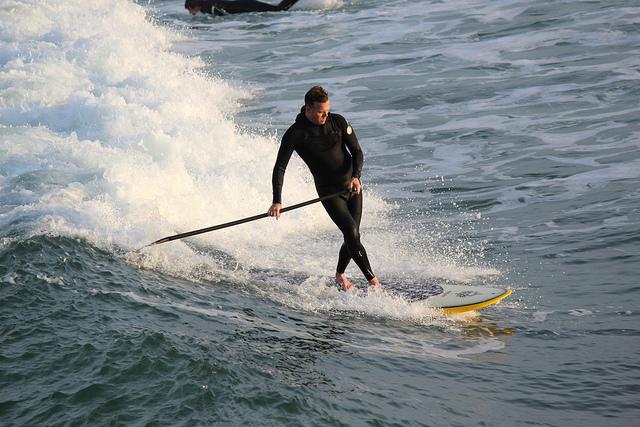What is the man holding on to?
Quick response, please. Paddle. What sport is this?
Give a very brief answer. Surfing. Is this person flying?
Answer briefly. No. IS that a women?
Short answer required. No. What is the surfers hand touching?
Answer briefly. Paddle. What does the person have in their hands?
Be succinct. Paddle. What is on the surfers ankle?
Write a very short answer. Strap. What is the man holding?
Quick response, please. Paddle. Which foot is the surfer using to control the surfboard?
Be succinct. Right. What is the man doing?
Short answer required. Paddle boarding. Is he swinging?
Keep it brief. No. What is this person standing on?
Short answer required. Surfboard. 